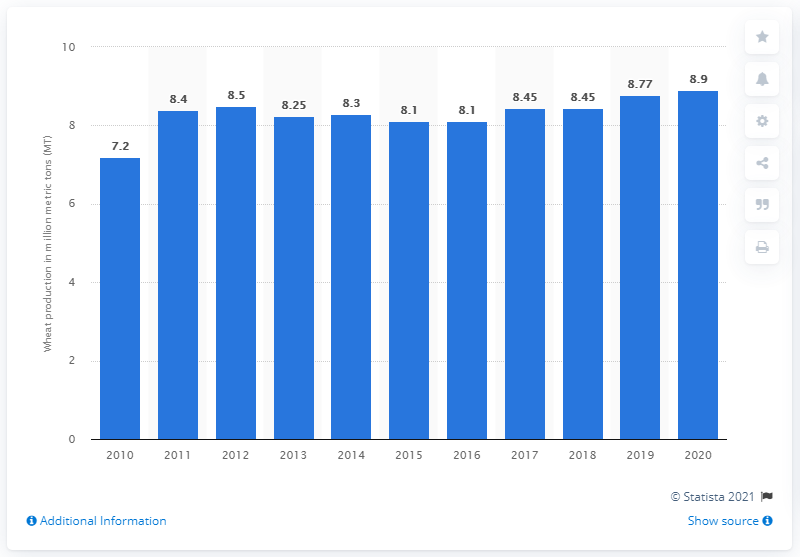Mention a couple of crucial points in this snapshot. In 2020, the wheat production in Egypt was 8.9 million metric tons. 